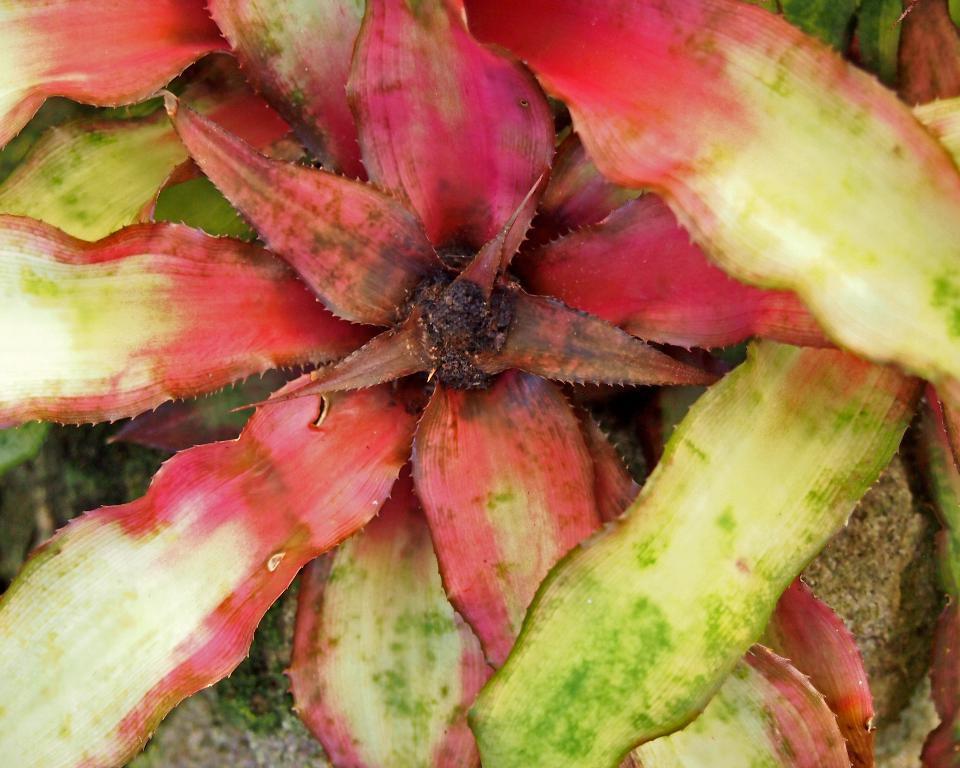Describe this image in one or two sentences. In the image there are leaves of a plant. 